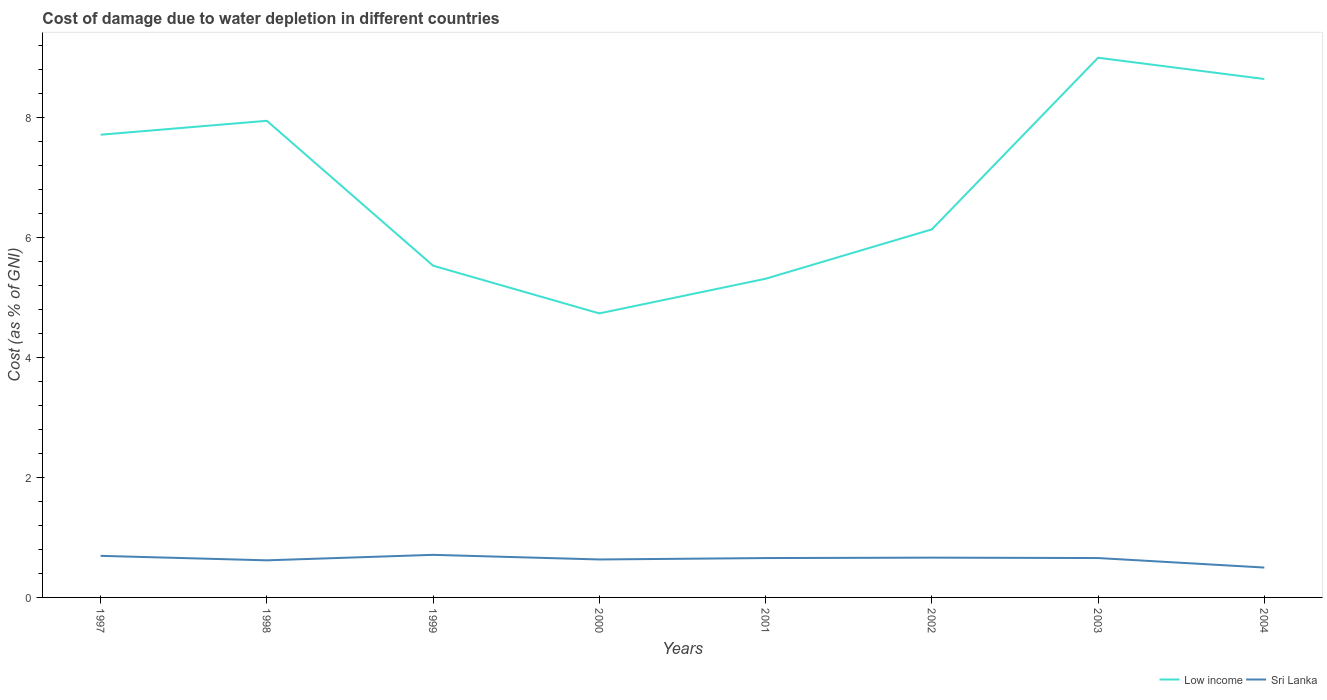How many different coloured lines are there?
Make the answer very short. 2. Is the number of lines equal to the number of legend labels?
Your answer should be compact. Yes. Across all years, what is the maximum cost of damage caused due to water depletion in Low income?
Ensure brevity in your answer.  4.73. What is the total cost of damage caused due to water depletion in Sri Lanka in the graph?
Your answer should be very brief. 0.16. What is the difference between the highest and the second highest cost of damage caused due to water depletion in Sri Lanka?
Offer a very short reply. 0.21. Is the cost of damage caused due to water depletion in Sri Lanka strictly greater than the cost of damage caused due to water depletion in Low income over the years?
Make the answer very short. Yes. What is the difference between two consecutive major ticks on the Y-axis?
Your answer should be very brief. 2. Does the graph contain any zero values?
Your answer should be very brief. No. Where does the legend appear in the graph?
Give a very brief answer. Bottom right. What is the title of the graph?
Your response must be concise. Cost of damage due to water depletion in different countries. What is the label or title of the X-axis?
Offer a terse response. Years. What is the label or title of the Y-axis?
Ensure brevity in your answer.  Cost (as % of GNI). What is the Cost (as % of GNI) in Low income in 1997?
Give a very brief answer. 7.71. What is the Cost (as % of GNI) in Sri Lanka in 1997?
Provide a succinct answer. 0.69. What is the Cost (as % of GNI) of Low income in 1998?
Make the answer very short. 7.94. What is the Cost (as % of GNI) in Sri Lanka in 1998?
Your answer should be compact. 0.62. What is the Cost (as % of GNI) in Low income in 1999?
Ensure brevity in your answer.  5.53. What is the Cost (as % of GNI) in Sri Lanka in 1999?
Your response must be concise. 0.71. What is the Cost (as % of GNI) of Low income in 2000?
Make the answer very short. 4.73. What is the Cost (as % of GNI) in Sri Lanka in 2000?
Provide a succinct answer. 0.63. What is the Cost (as % of GNI) in Low income in 2001?
Your answer should be compact. 5.31. What is the Cost (as % of GNI) in Sri Lanka in 2001?
Give a very brief answer. 0.66. What is the Cost (as % of GNI) in Low income in 2002?
Provide a short and direct response. 6.13. What is the Cost (as % of GNI) in Sri Lanka in 2002?
Provide a short and direct response. 0.66. What is the Cost (as % of GNI) in Low income in 2003?
Your answer should be compact. 8.99. What is the Cost (as % of GNI) of Sri Lanka in 2003?
Offer a very short reply. 0.66. What is the Cost (as % of GNI) of Low income in 2004?
Give a very brief answer. 8.64. What is the Cost (as % of GNI) in Sri Lanka in 2004?
Make the answer very short. 0.5. Across all years, what is the maximum Cost (as % of GNI) in Low income?
Provide a succinct answer. 8.99. Across all years, what is the maximum Cost (as % of GNI) in Sri Lanka?
Make the answer very short. 0.71. Across all years, what is the minimum Cost (as % of GNI) in Low income?
Make the answer very short. 4.73. Across all years, what is the minimum Cost (as % of GNI) of Sri Lanka?
Make the answer very short. 0.5. What is the total Cost (as % of GNI) in Low income in the graph?
Provide a short and direct response. 55. What is the total Cost (as % of GNI) of Sri Lanka in the graph?
Offer a terse response. 5.13. What is the difference between the Cost (as % of GNI) in Low income in 1997 and that in 1998?
Ensure brevity in your answer.  -0.23. What is the difference between the Cost (as % of GNI) of Sri Lanka in 1997 and that in 1998?
Provide a short and direct response. 0.07. What is the difference between the Cost (as % of GNI) in Low income in 1997 and that in 1999?
Your response must be concise. 2.18. What is the difference between the Cost (as % of GNI) in Sri Lanka in 1997 and that in 1999?
Offer a terse response. -0.02. What is the difference between the Cost (as % of GNI) of Low income in 1997 and that in 2000?
Offer a very short reply. 2.98. What is the difference between the Cost (as % of GNI) of Sri Lanka in 1997 and that in 2000?
Give a very brief answer. 0.06. What is the difference between the Cost (as % of GNI) in Low income in 1997 and that in 2001?
Give a very brief answer. 2.4. What is the difference between the Cost (as % of GNI) of Sri Lanka in 1997 and that in 2001?
Provide a succinct answer. 0.04. What is the difference between the Cost (as % of GNI) in Low income in 1997 and that in 2002?
Give a very brief answer. 1.58. What is the difference between the Cost (as % of GNI) in Sri Lanka in 1997 and that in 2002?
Your answer should be compact. 0.03. What is the difference between the Cost (as % of GNI) of Low income in 1997 and that in 2003?
Offer a very short reply. -1.28. What is the difference between the Cost (as % of GNI) of Sri Lanka in 1997 and that in 2003?
Make the answer very short. 0.04. What is the difference between the Cost (as % of GNI) of Low income in 1997 and that in 2004?
Provide a succinct answer. -0.93. What is the difference between the Cost (as % of GNI) in Sri Lanka in 1997 and that in 2004?
Make the answer very short. 0.19. What is the difference between the Cost (as % of GNI) in Low income in 1998 and that in 1999?
Give a very brief answer. 2.41. What is the difference between the Cost (as % of GNI) of Sri Lanka in 1998 and that in 1999?
Provide a short and direct response. -0.09. What is the difference between the Cost (as % of GNI) of Low income in 1998 and that in 2000?
Provide a short and direct response. 3.21. What is the difference between the Cost (as % of GNI) of Sri Lanka in 1998 and that in 2000?
Your answer should be very brief. -0.01. What is the difference between the Cost (as % of GNI) in Low income in 1998 and that in 2001?
Your response must be concise. 2.63. What is the difference between the Cost (as % of GNI) of Sri Lanka in 1998 and that in 2001?
Your answer should be very brief. -0.04. What is the difference between the Cost (as % of GNI) in Low income in 1998 and that in 2002?
Make the answer very short. 1.81. What is the difference between the Cost (as % of GNI) of Sri Lanka in 1998 and that in 2002?
Keep it short and to the point. -0.04. What is the difference between the Cost (as % of GNI) in Low income in 1998 and that in 2003?
Keep it short and to the point. -1.05. What is the difference between the Cost (as % of GNI) of Sri Lanka in 1998 and that in 2003?
Make the answer very short. -0.04. What is the difference between the Cost (as % of GNI) of Low income in 1998 and that in 2004?
Ensure brevity in your answer.  -0.7. What is the difference between the Cost (as % of GNI) in Sri Lanka in 1998 and that in 2004?
Ensure brevity in your answer.  0.12. What is the difference between the Cost (as % of GNI) in Low income in 1999 and that in 2000?
Your response must be concise. 0.8. What is the difference between the Cost (as % of GNI) in Sri Lanka in 1999 and that in 2000?
Your response must be concise. 0.08. What is the difference between the Cost (as % of GNI) in Low income in 1999 and that in 2001?
Offer a very short reply. 0.22. What is the difference between the Cost (as % of GNI) in Sri Lanka in 1999 and that in 2001?
Keep it short and to the point. 0.05. What is the difference between the Cost (as % of GNI) of Low income in 1999 and that in 2002?
Your response must be concise. -0.6. What is the difference between the Cost (as % of GNI) in Sri Lanka in 1999 and that in 2002?
Make the answer very short. 0.05. What is the difference between the Cost (as % of GNI) of Low income in 1999 and that in 2003?
Provide a short and direct response. -3.47. What is the difference between the Cost (as % of GNI) in Sri Lanka in 1999 and that in 2003?
Your response must be concise. 0.05. What is the difference between the Cost (as % of GNI) in Low income in 1999 and that in 2004?
Ensure brevity in your answer.  -3.11. What is the difference between the Cost (as % of GNI) in Sri Lanka in 1999 and that in 2004?
Ensure brevity in your answer.  0.21. What is the difference between the Cost (as % of GNI) of Low income in 2000 and that in 2001?
Ensure brevity in your answer.  -0.58. What is the difference between the Cost (as % of GNI) of Sri Lanka in 2000 and that in 2001?
Offer a very short reply. -0.02. What is the difference between the Cost (as % of GNI) in Sri Lanka in 2000 and that in 2002?
Make the answer very short. -0.03. What is the difference between the Cost (as % of GNI) in Low income in 2000 and that in 2003?
Provide a succinct answer. -4.26. What is the difference between the Cost (as % of GNI) of Sri Lanka in 2000 and that in 2003?
Offer a terse response. -0.02. What is the difference between the Cost (as % of GNI) in Low income in 2000 and that in 2004?
Provide a succinct answer. -3.91. What is the difference between the Cost (as % of GNI) in Sri Lanka in 2000 and that in 2004?
Your response must be concise. 0.13. What is the difference between the Cost (as % of GNI) of Low income in 2001 and that in 2002?
Your answer should be very brief. -0.82. What is the difference between the Cost (as % of GNI) in Sri Lanka in 2001 and that in 2002?
Give a very brief answer. -0.01. What is the difference between the Cost (as % of GNI) in Low income in 2001 and that in 2003?
Make the answer very short. -3.68. What is the difference between the Cost (as % of GNI) of Sri Lanka in 2001 and that in 2003?
Make the answer very short. -0. What is the difference between the Cost (as % of GNI) of Low income in 2001 and that in 2004?
Ensure brevity in your answer.  -3.33. What is the difference between the Cost (as % of GNI) of Sri Lanka in 2001 and that in 2004?
Ensure brevity in your answer.  0.16. What is the difference between the Cost (as % of GNI) in Low income in 2002 and that in 2003?
Your answer should be compact. -2.86. What is the difference between the Cost (as % of GNI) of Sri Lanka in 2002 and that in 2003?
Your answer should be very brief. 0.01. What is the difference between the Cost (as % of GNI) of Low income in 2002 and that in 2004?
Keep it short and to the point. -2.51. What is the difference between the Cost (as % of GNI) of Sri Lanka in 2002 and that in 2004?
Ensure brevity in your answer.  0.17. What is the difference between the Cost (as % of GNI) in Low income in 2003 and that in 2004?
Offer a very short reply. 0.35. What is the difference between the Cost (as % of GNI) of Sri Lanka in 2003 and that in 2004?
Give a very brief answer. 0.16. What is the difference between the Cost (as % of GNI) in Low income in 1997 and the Cost (as % of GNI) in Sri Lanka in 1998?
Provide a short and direct response. 7.09. What is the difference between the Cost (as % of GNI) in Low income in 1997 and the Cost (as % of GNI) in Sri Lanka in 1999?
Provide a succinct answer. 7. What is the difference between the Cost (as % of GNI) of Low income in 1997 and the Cost (as % of GNI) of Sri Lanka in 2000?
Keep it short and to the point. 7.08. What is the difference between the Cost (as % of GNI) in Low income in 1997 and the Cost (as % of GNI) in Sri Lanka in 2001?
Offer a terse response. 7.06. What is the difference between the Cost (as % of GNI) in Low income in 1997 and the Cost (as % of GNI) in Sri Lanka in 2002?
Provide a succinct answer. 7.05. What is the difference between the Cost (as % of GNI) of Low income in 1997 and the Cost (as % of GNI) of Sri Lanka in 2003?
Ensure brevity in your answer.  7.06. What is the difference between the Cost (as % of GNI) of Low income in 1997 and the Cost (as % of GNI) of Sri Lanka in 2004?
Offer a very short reply. 7.21. What is the difference between the Cost (as % of GNI) of Low income in 1998 and the Cost (as % of GNI) of Sri Lanka in 1999?
Provide a succinct answer. 7.23. What is the difference between the Cost (as % of GNI) in Low income in 1998 and the Cost (as % of GNI) in Sri Lanka in 2000?
Keep it short and to the point. 7.31. What is the difference between the Cost (as % of GNI) in Low income in 1998 and the Cost (as % of GNI) in Sri Lanka in 2001?
Keep it short and to the point. 7.29. What is the difference between the Cost (as % of GNI) of Low income in 1998 and the Cost (as % of GNI) of Sri Lanka in 2002?
Provide a succinct answer. 7.28. What is the difference between the Cost (as % of GNI) in Low income in 1998 and the Cost (as % of GNI) in Sri Lanka in 2003?
Your answer should be very brief. 7.29. What is the difference between the Cost (as % of GNI) in Low income in 1998 and the Cost (as % of GNI) in Sri Lanka in 2004?
Offer a terse response. 7.45. What is the difference between the Cost (as % of GNI) of Low income in 1999 and the Cost (as % of GNI) of Sri Lanka in 2000?
Provide a succinct answer. 4.9. What is the difference between the Cost (as % of GNI) of Low income in 1999 and the Cost (as % of GNI) of Sri Lanka in 2001?
Offer a very short reply. 4.87. What is the difference between the Cost (as % of GNI) of Low income in 1999 and the Cost (as % of GNI) of Sri Lanka in 2002?
Keep it short and to the point. 4.87. What is the difference between the Cost (as % of GNI) in Low income in 1999 and the Cost (as % of GNI) in Sri Lanka in 2003?
Keep it short and to the point. 4.87. What is the difference between the Cost (as % of GNI) in Low income in 1999 and the Cost (as % of GNI) in Sri Lanka in 2004?
Offer a very short reply. 5.03. What is the difference between the Cost (as % of GNI) in Low income in 2000 and the Cost (as % of GNI) in Sri Lanka in 2001?
Make the answer very short. 4.08. What is the difference between the Cost (as % of GNI) in Low income in 2000 and the Cost (as % of GNI) in Sri Lanka in 2002?
Your answer should be very brief. 4.07. What is the difference between the Cost (as % of GNI) of Low income in 2000 and the Cost (as % of GNI) of Sri Lanka in 2003?
Make the answer very short. 4.08. What is the difference between the Cost (as % of GNI) in Low income in 2000 and the Cost (as % of GNI) in Sri Lanka in 2004?
Your answer should be very brief. 4.24. What is the difference between the Cost (as % of GNI) of Low income in 2001 and the Cost (as % of GNI) of Sri Lanka in 2002?
Ensure brevity in your answer.  4.65. What is the difference between the Cost (as % of GNI) of Low income in 2001 and the Cost (as % of GNI) of Sri Lanka in 2003?
Ensure brevity in your answer.  4.65. What is the difference between the Cost (as % of GNI) in Low income in 2001 and the Cost (as % of GNI) in Sri Lanka in 2004?
Your answer should be compact. 4.81. What is the difference between the Cost (as % of GNI) in Low income in 2002 and the Cost (as % of GNI) in Sri Lanka in 2003?
Provide a succinct answer. 5.48. What is the difference between the Cost (as % of GNI) of Low income in 2002 and the Cost (as % of GNI) of Sri Lanka in 2004?
Your response must be concise. 5.64. What is the difference between the Cost (as % of GNI) of Low income in 2003 and the Cost (as % of GNI) of Sri Lanka in 2004?
Provide a short and direct response. 8.5. What is the average Cost (as % of GNI) of Low income per year?
Provide a short and direct response. 6.87. What is the average Cost (as % of GNI) in Sri Lanka per year?
Your response must be concise. 0.64. In the year 1997, what is the difference between the Cost (as % of GNI) of Low income and Cost (as % of GNI) of Sri Lanka?
Offer a very short reply. 7.02. In the year 1998, what is the difference between the Cost (as % of GNI) in Low income and Cost (as % of GNI) in Sri Lanka?
Keep it short and to the point. 7.33. In the year 1999, what is the difference between the Cost (as % of GNI) of Low income and Cost (as % of GNI) of Sri Lanka?
Provide a short and direct response. 4.82. In the year 2000, what is the difference between the Cost (as % of GNI) of Low income and Cost (as % of GNI) of Sri Lanka?
Provide a short and direct response. 4.1. In the year 2001, what is the difference between the Cost (as % of GNI) of Low income and Cost (as % of GNI) of Sri Lanka?
Offer a terse response. 4.66. In the year 2002, what is the difference between the Cost (as % of GNI) in Low income and Cost (as % of GNI) in Sri Lanka?
Offer a very short reply. 5.47. In the year 2003, what is the difference between the Cost (as % of GNI) in Low income and Cost (as % of GNI) in Sri Lanka?
Give a very brief answer. 8.34. In the year 2004, what is the difference between the Cost (as % of GNI) of Low income and Cost (as % of GNI) of Sri Lanka?
Your answer should be very brief. 8.14. What is the ratio of the Cost (as % of GNI) of Low income in 1997 to that in 1998?
Provide a short and direct response. 0.97. What is the ratio of the Cost (as % of GNI) in Sri Lanka in 1997 to that in 1998?
Provide a succinct answer. 1.12. What is the ratio of the Cost (as % of GNI) of Low income in 1997 to that in 1999?
Offer a very short reply. 1.39. What is the ratio of the Cost (as % of GNI) in Sri Lanka in 1997 to that in 1999?
Make the answer very short. 0.98. What is the ratio of the Cost (as % of GNI) of Low income in 1997 to that in 2000?
Keep it short and to the point. 1.63. What is the ratio of the Cost (as % of GNI) in Sri Lanka in 1997 to that in 2000?
Your answer should be very brief. 1.1. What is the ratio of the Cost (as % of GNI) of Low income in 1997 to that in 2001?
Keep it short and to the point. 1.45. What is the ratio of the Cost (as % of GNI) of Sri Lanka in 1997 to that in 2001?
Your answer should be very brief. 1.06. What is the ratio of the Cost (as % of GNI) of Low income in 1997 to that in 2002?
Make the answer very short. 1.26. What is the ratio of the Cost (as % of GNI) in Sri Lanka in 1997 to that in 2002?
Your answer should be very brief. 1.04. What is the ratio of the Cost (as % of GNI) of Low income in 1997 to that in 2003?
Ensure brevity in your answer.  0.86. What is the ratio of the Cost (as % of GNI) in Sri Lanka in 1997 to that in 2003?
Offer a terse response. 1.06. What is the ratio of the Cost (as % of GNI) of Low income in 1997 to that in 2004?
Offer a very short reply. 0.89. What is the ratio of the Cost (as % of GNI) of Sri Lanka in 1997 to that in 2004?
Your answer should be very brief. 1.39. What is the ratio of the Cost (as % of GNI) in Low income in 1998 to that in 1999?
Offer a very short reply. 1.44. What is the ratio of the Cost (as % of GNI) of Sri Lanka in 1998 to that in 1999?
Make the answer very short. 0.87. What is the ratio of the Cost (as % of GNI) of Low income in 1998 to that in 2000?
Your answer should be very brief. 1.68. What is the ratio of the Cost (as % of GNI) in Sri Lanka in 1998 to that in 2000?
Ensure brevity in your answer.  0.98. What is the ratio of the Cost (as % of GNI) in Low income in 1998 to that in 2001?
Your response must be concise. 1.5. What is the ratio of the Cost (as % of GNI) of Sri Lanka in 1998 to that in 2001?
Offer a very short reply. 0.94. What is the ratio of the Cost (as % of GNI) in Low income in 1998 to that in 2002?
Ensure brevity in your answer.  1.3. What is the ratio of the Cost (as % of GNI) in Sri Lanka in 1998 to that in 2002?
Provide a succinct answer. 0.93. What is the ratio of the Cost (as % of GNI) in Low income in 1998 to that in 2003?
Your response must be concise. 0.88. What is the ratio of the Cost (as % of GNI) of Sri Lanka in 1998 to that in 2003?
Provide a succinct answer. 0.94. What is the ratio of the Cost (as % of GNI) in Low income in 1998 to that in 2004?
Offer a very short reply. 0.92. What is the ratio of the Cost (as % of GNI) in Sri Lanka in 1998 to that in 2004?
Provide a succinct answer. 1.24. What is the ratio of the Cost (as % of GNI) in Low income in 1999 to that in 2000?
Give a very brief answer. 1.17. What is the ratio of the Cost (as % of GNI) of Sri Lanka in 1999 to that in 2000?
Provide a short and direct response. 1.12. What is the ratio of the Cost (as % of GNI) in Low income in 1999 to that in 2001?
Keep it short and to the point. 1.04. What is the ratio of the Cost (as % of GNI) of Sri Lanka in 1999 to that in 2001?
Provide a short and direct response. 1.08. What is the ratio of the Cost (as % of GNI) of Low income in 1999 to that in 2002?
Make the answer very short. 0.9. What is the ratio of the Cost (as % of GNI) in Sri Lanka in 1999 to that in 2002?
Keep it short and to the point. 1.07. What is the ratio of the Cost (as % of GNI) of Low income in 1999 to that in 2003?
Provide a succinct answer. 0.61. What is the ratio of the Cost (as % of GNI) of Sri Lanka in 1999 to that in 2003?
Provide a succinct answer. 1.08. What is the ratio of the Cost (as % of GNI) of Low income in 1999 to that in 2004?
Your response must be concise. 0.64. What is the ratio of the Cost (as % of GNI) in Sri Lanka in 1999 to that in 2004?
Offer a very short reply. 1.43. What is the ratio of the Cost (as % of GNI) of Low income in 2000 to that in 2001?
Keep it short and to the point. 0.89. What is the ratio of the Cost (as % of GNI) of Low income in 2000 to that in 2002?
Offer a very short reply. 0.77. What is the ratio of the Cost (as % of GNI) of Sri Lanka in 2000 to that in 2002?
Your answer should be compact. 0.95. What is the ratio of the Cost (as % of GNI) in Low income in 2000 to that in 2003?
Ensure brevity in your answer.  0.53. What is the ratio of the Cost (as % of GNI) in Sri Lanka in 2000 to that in 2003?
Ensure brevity in your answer.  0.96. What is the ratio of the Cost (as % of GNI) of Low income in 2000 to that in 2004?
Provide a succinct answer. 0.55. What is the ratio of the Cost (as % of GNI) of Sri Lanka in 2000 to that in 2004?
Keep it short and to the point. 1.27. What is the ratio of the Cost (as % of GNI) in Low income in 2001 to that in 2002?
Ensure brevity in your answer.  0.87. What is the ratio of the Cost (as % of GNI) of Sri Lanka in 2001 to that in 2002?
Your response must be concise. 0.99. What is the ratio of the Cost (as % of GNI) in Low income in 2001 to that in 2003?
Ensure brevity in your answer.  0.59. What is the ratio of the Cost (as % of GNI) of Low income in 2001 to that in 2004?
Provide a short and direct response. 0.61. What is the ratio of the Cost (as % of GNI) in Sri Lanka in 2001 to that in 2004?
Your response must be concise. 1.32. What is the ratio of the Cost (as % of GNI) of Low income in 2002 to that in 2003?
Offer a very short reply. 0.68. What is the ratio of the Cost (as % of GNI) in Sri Lanka in 2002 to that in 2003?
Ensure brevity in your answer.  1.01. What is the ratio of the Cost (as % of GNI) of Low income in 2002 to that in 2004?
Offer a terse response. 0.71. What is the ratio of the Cost (as % of GNI) of Sri Lanka in 2002 to that in 2004?
Make the answer very short. 1.33. What is the ratio of the Cost (as % of GNI) in Low income in 2003 to that in 2004?
Give a very brief answer. 1.04. What is the ratio of the Cost (as % of GNI) of Sri Lanka in 2003 to that in 2004?
Ensure brevity in your answer.  1.32. What is the difference between the highest and the second highest Cost (as % of GNI) of Low income?
Offer a terse response. 0.35. What is the difference between the highest and the second highest Cost (as % of GNI) of Sri Lanka?
Keep it short and to the point. 0.02. What is the difference between the highest and the lowest Cost (as % of GNI) of Low income?
Keep it short and to the point. 4.26. What is the difference between the highest and the lowest Cost (as % of GNI) of Sri Lanka?
Offer a very short reply. 0.21. 